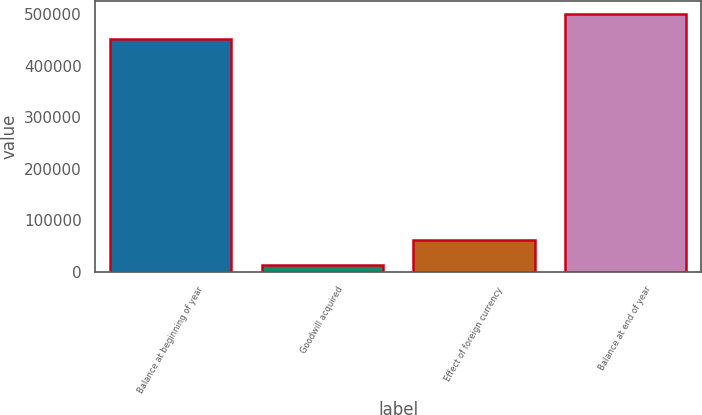Convert chart to OTSL. <chart><loc_0><loc_0><loc_500><loc_500><bar_chart><fcel>Balance at beginning of year<fcel>Goodwill acquired<fcel>Effect of foreign currency<fcel>Balance at end of year<nl><fcel>451244<fcel>13536<fcel>61896<fcel>499604<nl></chart> 